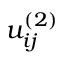Convert formula to latex. <formula><loc_0><loc_0><loc_500><loc_500>u _ { i j } ^ { ( 2 ) }</formula> 